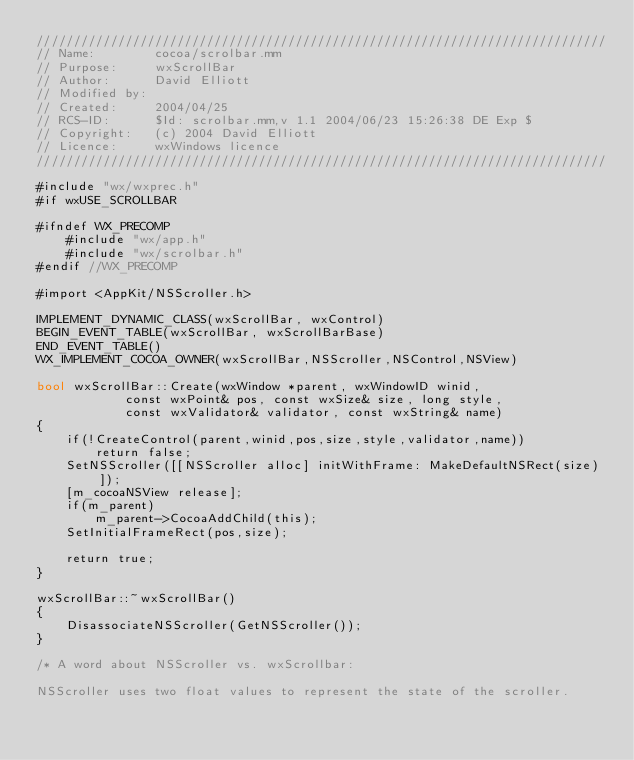Convert code to text. <code><loc_0><loc_0><loc_500><loc_500><_ObjectiveC_>/////////////////////////////////////////////////////////////////////////////
// Name:        cocoa/scrolbar.mm
// Purpose:     wxScrollBar
// Author:      David Elliott
// Modified by:
// Created:     2004/04/25
// RCS-ID:      $Id: scrolbar.mm,v 1.1 2004/06/23 15:26:38 DE Exp $
// Copyright:   (c) 2004 David Elliott
// Licence:   	wxWindows licence
/////////////////////////////////////////////////////////////////////////////

#include "wx/wxprec.h"
#if wxUSE_SCROLLBAR

#ifndef WX_PRECOMP
    #include "wx/app.h"
    #include "wx/scrolbar.h"
#endif //WX_PRECOMP

#import <AppKit/NSScroller.h>

IMPLEMENT_DYNAMIC_CLASS(wxScrollBar, wxControl)
BEGIN_EVENT_TABLE(wxScrollBar, wxScrollBarBase)
END_EVENT_TABLE()
WX_IMPLEMENT_COCOA_OWNER(wxScrollBar,NSScroller,NSControl,NSView)

bool wxScrollBar::Create(wxWindow *parent, wxWindowID winid,
            const wxPoint& pos, const wxSize& size, long style,
            const wxValidator& validator, const wxString& name)
{
    if(!CreateControl(parent,winid,pos,size,style,validator,name))
        return false;
    SetNSScroller([[NSScroller alloc] initWithFrame: MakeDefaultNSRect(size)]);
    [m_cocoaNSView release];
    if(m_parent)
        m_parent->CocoaAddChild(this);
    SetInitialFrameRect(pos,size);

    return true;
}

wxScrollBar::~wxScrollBar()
{
    DisassociateNSScroller(GetNSScroller());
}

/* A word about NSScroller vs. wxScrollbar:

NSScroller uses two float values to represent the state of the scroller.</code> 